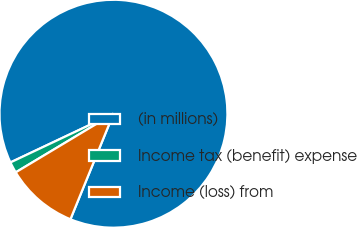<chart> <loc_0><loc_0><loc_500><loc_500><pie_chart><fcel>(in millions)<fcel>Income tax (benefit) expense<fcel>Income (loss) from<nl><fcel>88.19%<fcel>1.57%<fcel>10.24%<nl></chart> 